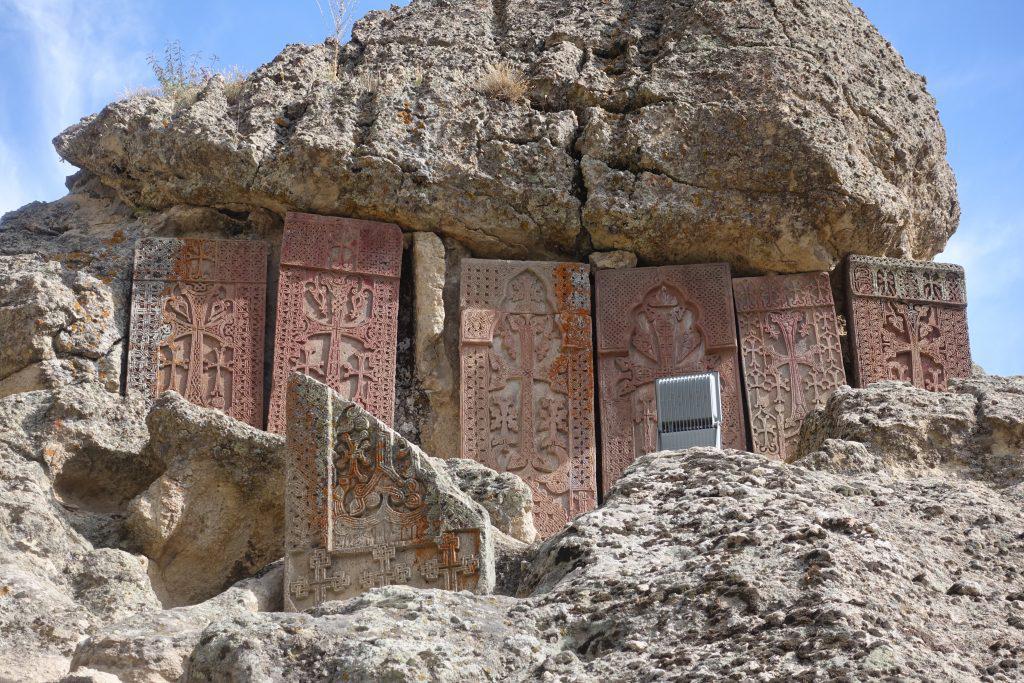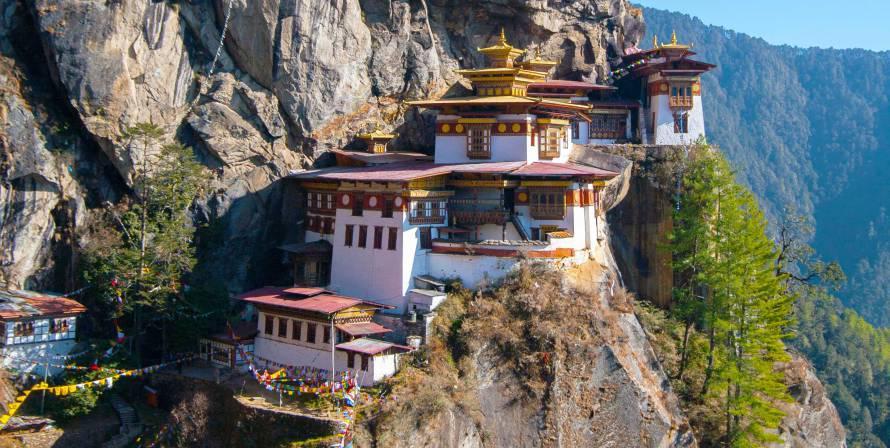The first image is the image on the left, the second image is the image on the right. For the images displayed, is the sentence "The structure in the image on the right appears to have been hewn from the mountain." factually correct? Answer yes or no. Yes. 